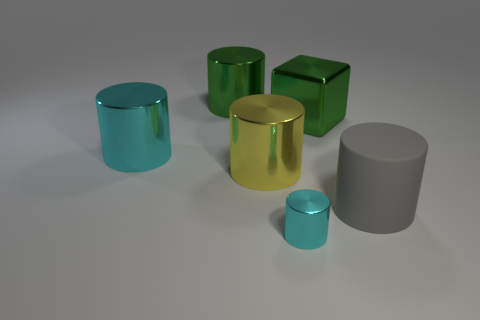What is the color of the tiny cylinder that is made of the same material as the cube? The color of the small cylinder, which shares the same glossy, metallic appearance as the cube, is a light shade of cyan, reflecting a serene yet sophisticated aesthetic in the composition. 